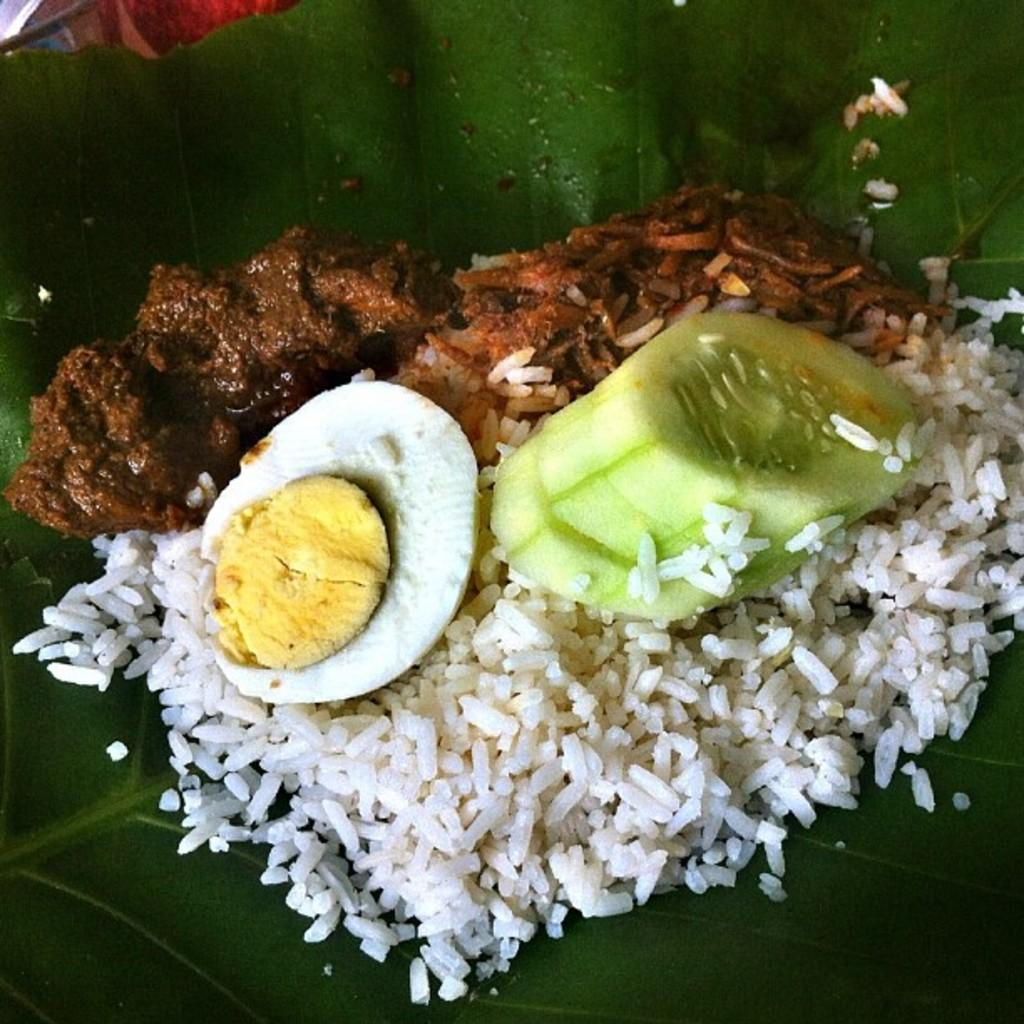What is the main food item placed on in the image? There is food on a leaf in the image. What type of food can be seen in the image besides the food on the leaf? There is an egg and pieces of cucumber in the image. What other type of food is present in the image? There is rice in the image. How does the copy machine work in the image? There is no copy machine present in the image. What is the head of the person doing in the image? There is no person present in the image, so it is not possible to describe the actions of a head. 